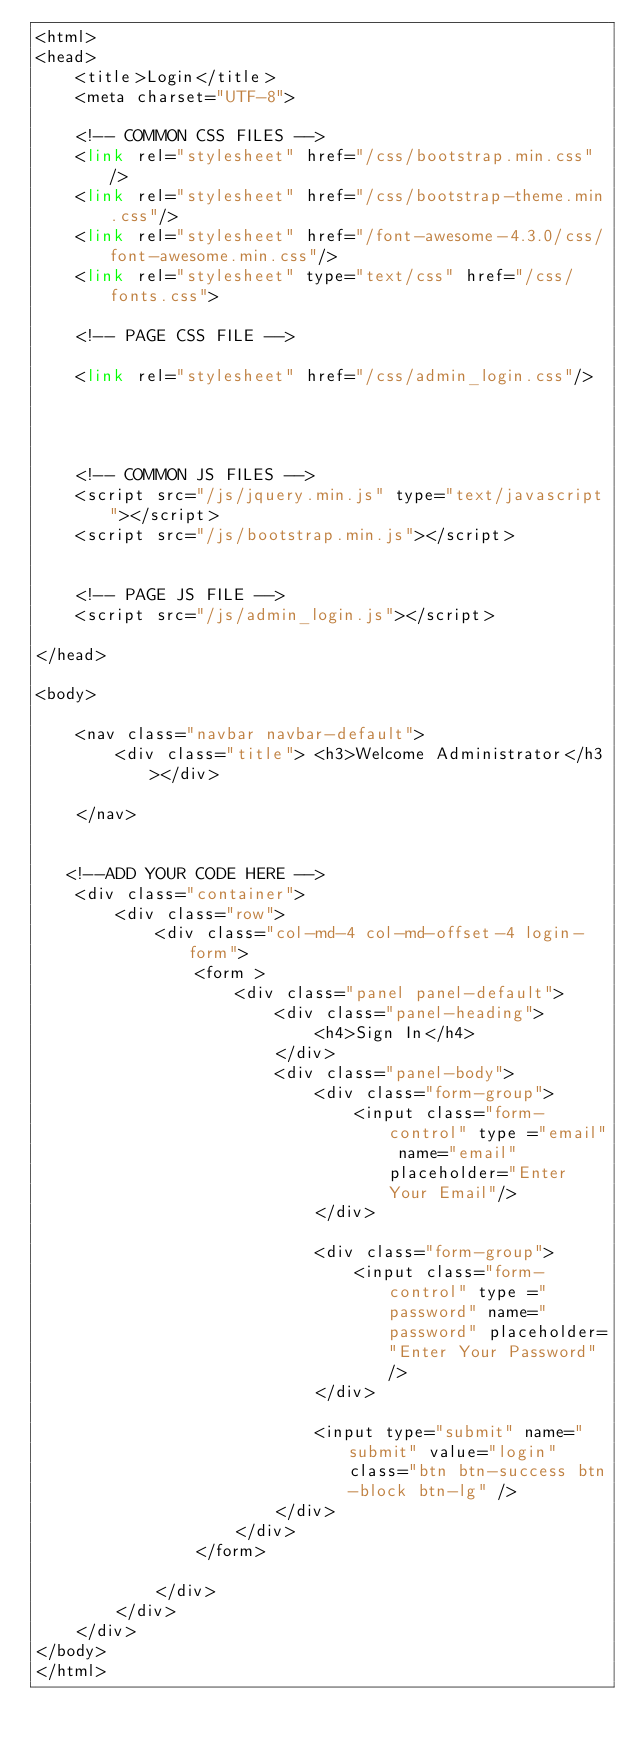<code> <loc_0><loc_0><loc_500><loc_500><_PHP_><html>
<head>
    <title>Login</title>
    <meta charset="UTF-8">

    <!-- COMMON CSS FILES -->
    <link rel="stylesheet" href="/css/bootstrap.min.css"/>
    <link rel="stylesheet" href="/css/bootstrap-theme.min.css"/>
    <link rel="stylesheet" href="/font-awesome-4.3.0/css/font-awesome.min.css"/>
    <link rel="stylesheet" type="text/css" href="/css/fonts.css">

    <!-- PAGE CSS FILE -->

    <link rel="stylesheet" href="/css/admin_login.css"/>




    <!-- COMMON JS FILES -->
    <script src="/js/jquery.min.js" type="text/javascript"></script>
    <script src="/js/bootstrap.min.js"></script>


    <!-- PAGE JS FILE -->
    <script src="/js/admin_login.js"></script>

</head>

<body>

    <nav class="navbar navbar-default">
        <div class="title"> <h3>Welcome Administrator</h3></div>

    </nav>


   <!--ADD YOUR CODE HERE -->
    <div class="container">
        <div class="row">
            <div class="col-md-4 col-md-offset-4 login-form">
                <form >
                    <div class="panel panel-default">
                        <div class="panel-heading">
                            <h4>Sign In</h4>
                        </div>
                        <div class="panel-body">
                            <div class="form-group">
                                <input class="form-control" type ="email" name="email" placeholder="Enter Your Email"/>
                            </div>

                            <div class="form-group">
                                <input class="form-control" type ="password" name="password" placeholder="Enter Your Password" />
                            </div>

                            <input type="submit" name="submit" value="login" class="btn btn-success btn-block btn-lg" />
                        </div>
                    </div>
                </form>

            </div>
        </div>
    </div>
</body>
</html></code> 